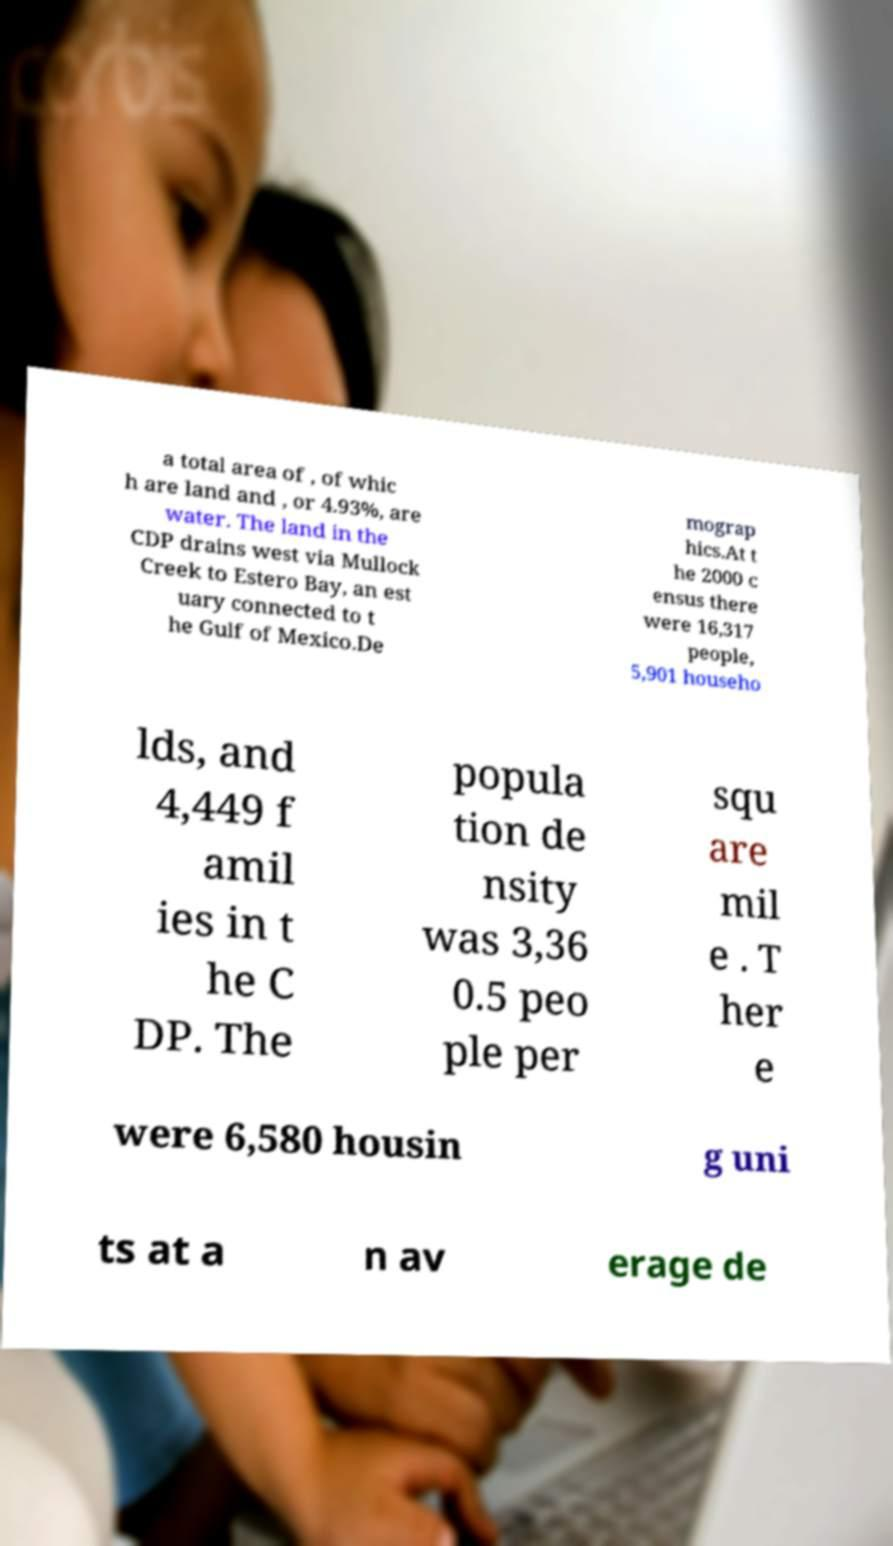What messages or text are displayed in this image? I need them in a readable, typed format. a total area of , of whic h are land and , or 4.93%, are water. The land in the CDP drains west via Mullock Creek to Estero Bay, an est uary connected to t he Gulf of Mexico.De mograp hics.At t he 2000 c ensus there were 16,317 people, 5,901 househo lds, and 4,449 f amil ies in t he C DP. The popula tion de nsity was 3,36 0.5 peo ple per squ are mil e . T her e were 6,580 housin g uni ts at a n av erage de 